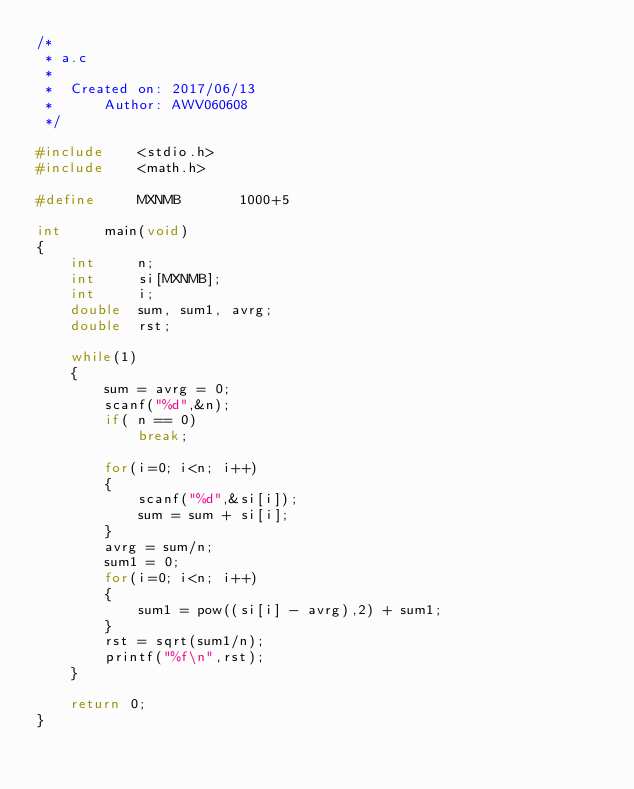Convert code to text. <code><loc_0><loc_0><loc_500><loc_500><_C_>/*
 * a.c
 *
 *  Created on: 2017/06/13
 *      Author: AWV060608
 */

#include	<stdio.h>
#include	<math.h>

#define		MXNMB		1000+5

int		main(void)
{
	int		n;
	int		si[MXNMB];
	int		i;
	double	sum, sum1, avrg;
	double	rst;

	while(1)
	{
		sum = avrg = 0;
		scanf("%d",&n);
		if( n == 0)
			break;

		for(i=0; i<n; i++)
		{
			scanf("%d",&si[i]);
			sum = sum + si[i];
		}
		avrg = sum/n;
		sum1 = 0;
		for(i=0; i<n; i++)
		{
			sum1 = pow((si[i] - avrg),2) + sum1;
		}
		rst = sqrt(sum1/n);
		printf("%f\n",rst);
	}

	return 0;
}</code> 